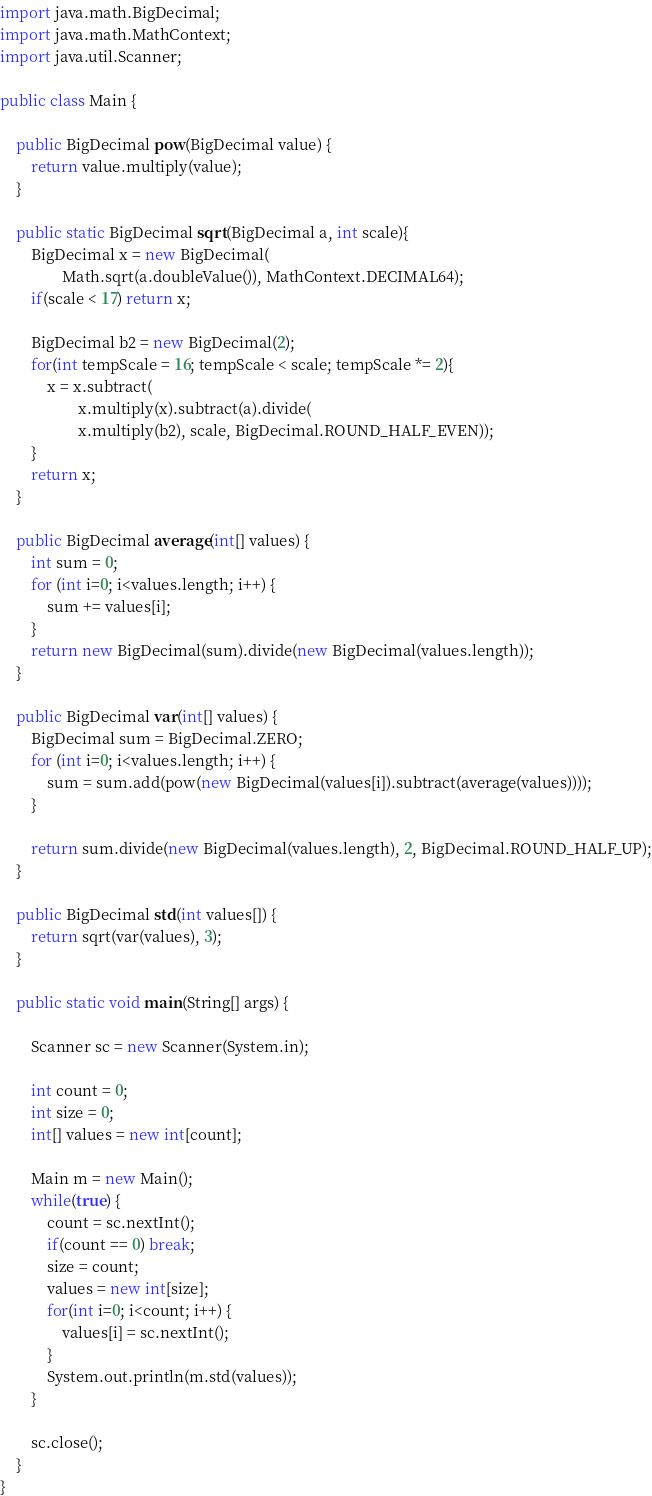<code> <loc_0><loc_0><loc_500><loc_500><_Java_>import java.math.BigDecimal;
import java.math.MathContext;
import java.util.Scanner;

public class Main {

    public BigDecimal pow(BigDecimal value) {
        return value.multiply(value);
    }

    public static BigDecimal sqrt(BigDecimal a, int scale){
        BigDecimal x = new BigDecimal(
                Math.sqrt(a.doubleValue()), MathContext.DECIMAL64);
        if(scale < 17) return x;

        BigDecimal b2 = new BigDecimal(2);
        for(int tempScale = 16; tempScale < scale; tempScale *= 2){
            x = x.subtract(
                    x.multiply(x).subtract(a).divide(
                    x.multiply(b2), scale, BigDecimal.ROUND_HALF_EVEN));
        }
        return x;
    }

    public BigDecimal average(int[] values) {
        int sum = 0;
        for (int i=0; i<values.length; i++) {
            sum += values[i];
        }
        return new BigDecimal(sum).divide(new BigDecimal(values.length));
    }

    public BigDecimal var(int[] values) {
        BigDecimal sum = BigDecimal.ZERO;
        for (int i=0; i<values.length; i++) {
            sum = sum.add(pow(new BigDecimal(values[i]).subtract(average(values))));
        }

        return sum.divide(new BigDecimal(values.length), 2, BigDecimal.ROUND_HALF_UP);
    }

    public BigDecimal std(int values[]) {
        return sqrt(var(values), 3);
    }

    public static void main(String[] args) {

    	Scanner sc = new Scanner(System.in);

        int count = 0;
        int size = 0;
        int[] values = new int[count];

        Main m = new Main();
        while(true) {
        	count = sc.nextInt();
        	if(count == 0) break;
            size = count;
            values = new int[size];
        	for(int i=0; i<count; i++) {
        		values[i] = sc.nextInt();
        	}
        	System.out.println(m.std(values));
        }

        sc.close();
    }
}
</code> 